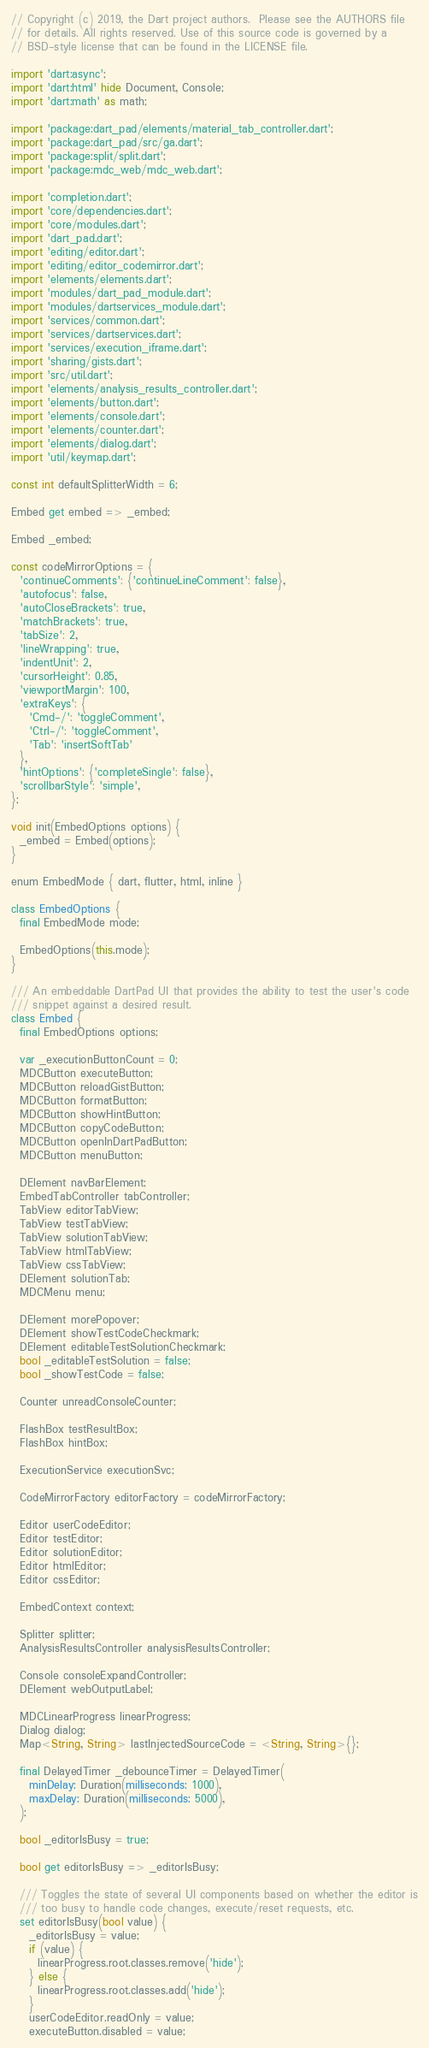<code> <loc_0><loc_0><loc_500><loc_500><_Dart_>// Copyright (c) 2019, the Dart project authors.  Please see the AUTHORS file
// for details. All rights reserved. Use of this source code is governed by a
// BSD-style license that can be found in the LICENSE file.

import 'dart:async';
import 'dart:html' hide Document, Console;
import 'dart:math' as math;

import 'package:dart_pad/elements/material_tab_controller.dart';
import 'package:dart_pad/src/ga.dart';
import 'package:split/split.dart';
import 'package:mdc_web/mdc_web.dart';

import 'completion.dart';
import 'core/dependencies.dart';
import 'core/modules.dart';
import 'dart_pad.dart';
import 'editing/editor.dart';
import 'editing/editor_codemirror.dart';
import 'elements/elements.dart';
import 'modules/dart_pad_module.dart';
import 'modules/dartservices_module.dart';
import 'services/common.dart';
import 'services/dartservices.dart';
import 'services/execution_iframe.dart';
import 'sharing/gists.dart';
import 'src/util.dart';
import 'elements/analysis_results_controller.dart';
import 'elements/button.dart';
import 'elements/console.dart';
import 'elements/counter.dart';
import 'elements/dialog.dart';
import 'util/keymap.dart';

const int defaultSplitterWidth = 6;

Embed get embed => _embed;

Embed _embed;

const codeMirrorOptions = {
  'continueComments': {'continueLineComment': false},
  'autofocus': false,
  'autoCloseBrackets': true,
  'matchBrackets': true,
  'tabSize': 2,
  'lineWrapping': true,
  'indentUnit': 2,
  'cursorHeight': 0.85,
  'viewportMargin': 100,
  'extraKeys': {
    'Cmd-/': 'toggleComment',
    'Ctrl-/': 'toggleComment',
    'Tab': 'insertSoftTab'
  },
  'hintOptions': {'completeSingle': false},
  'scrollbarStyle': 'simple',
};

void init(EmbedOptions options) {
  _embed = Embed(options);
}

enum EmbedMode { dart, flutter, html, inline }

class EmbedOptions {
  final EmbedMode mode;

  EmbedOptions(this.mode);
}

/// An embeddable DartPad UI that provides the ability to test the user's code
/// snippet against a desired result.
class Embed {
  final EmbedOptions options;

  var _executionButtonCount = 0;
  MDCButton executeButton;
  MDCButton reloadGistButton;
  MDCButton formatButton;
  MDCButton showHintButton;
  MDCButton copyCodeButton;
  MDCButton openInDartPadButton;
  MDCButton menuButton;

  DElement navBarElement;
  EmbedTabController tabController;
  TabView editorTabView;
  TabView testTabView;
  TabView solutionTabView;
  TabView htmlTabView;
  TabView cssTabView;
  DElement solutionTab;
  MDCMenu menu;

  DElement morePopover;
  DElement showTestCodeCheckmark;
  DElement editableTestSolutionCheckmark;
  bool _editableTestSolution = false;
  bool _showTestCode = false;

  Counter unreadConsoleCounter;

  FlashBox testResultBox;
  FlashBox hintBox;

  ExecutionService executionSvc;

  CodeMirrorFactory editorFactory = codeMirrorFactory;

  Editor userCodeEditor;
  Editor testEditor;
  Editor solutionEditor;
  Editor htmlEditor;
  Editor cssEditor;

  EmbedContext context;

  Splitter splitter;
  AnalysisResultsController analysisResultsController;

  Console consoleExpandController;
  DElement webOutputLabel;

  MDCLinearProgress linearProgress;
  Dialog dialog;
  Map<String, String> lastInjectedSourceCode = <String, String>{};

  final DelayedTimer _debounceTimer = DelayedTimer(
    minDelay: Duration(milliseconds: 1000),
    maxDelay: Duration(milliseconds: 5000),
  );

  bool _editorIsBusy = true;

  bool get editorIsBusy => _editorIsBusy;

  /// Toggles the state of several UI components based on whether the editor is
  /// too busy to handle code changes, execute/reset requests, etc.
  set editorIsBusy(bool value) {
    _editorIsBusy = value;
    if (value) {
      linearProgress.root.classes.remove('hide');
    } else {
      linearProgress.root.classes.add('hide');
    }
    userCodeEditor.readOnly = value;
    executeButton.disabled = value;</code> 